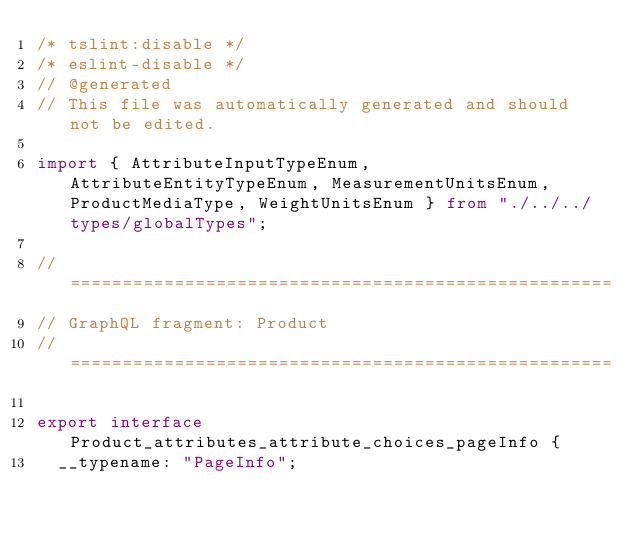<code> <loc_0><loc_0><loc_500><loc_500><_TypeScript_>/* tslint:disable */
/* eslint-disable */
// @generated
// This file was automatically generated and should not be edited.

import { AttributeInputTypeEnum, AttributeEntityTypeEnum, MeasurementUnitsEnum, ProductMediaType, WeightUnitsEnum } from "./../../types/globalTypes";

// ====================================================
// GraphQL fragment: Product
// ====================================================

export interface Product_attributes_attribute_choices_pageInfo {
  __typename: "PageInfo";</code> 